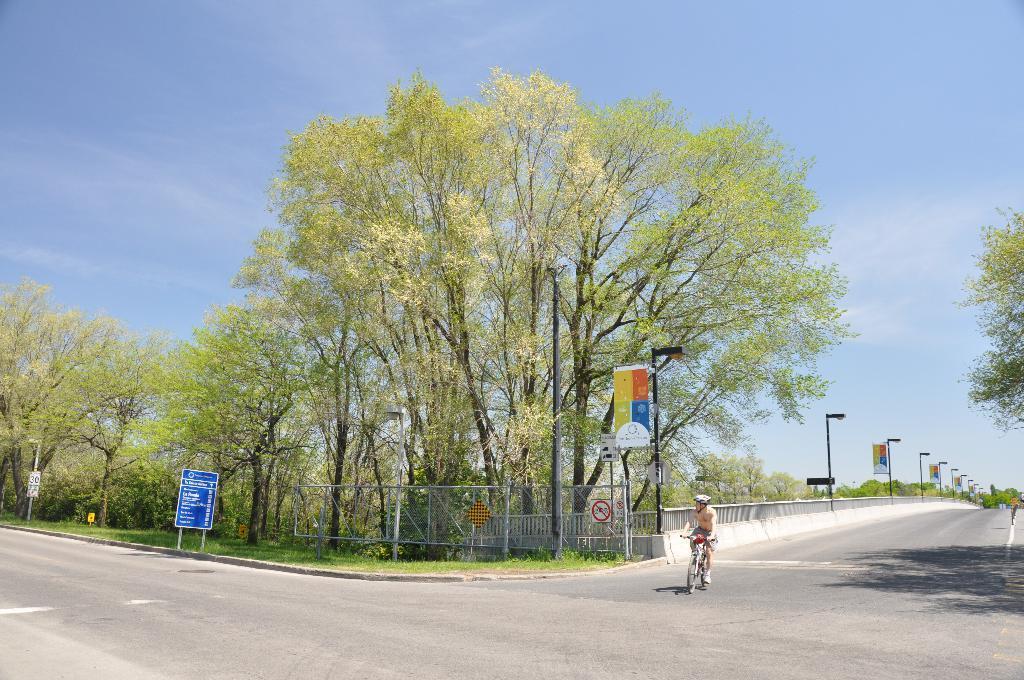Can you describe this image briefly? There is a person riding a bicycle on the road. Here we can see poles, boards, grass, fence, and trees. In the background there is sky. 